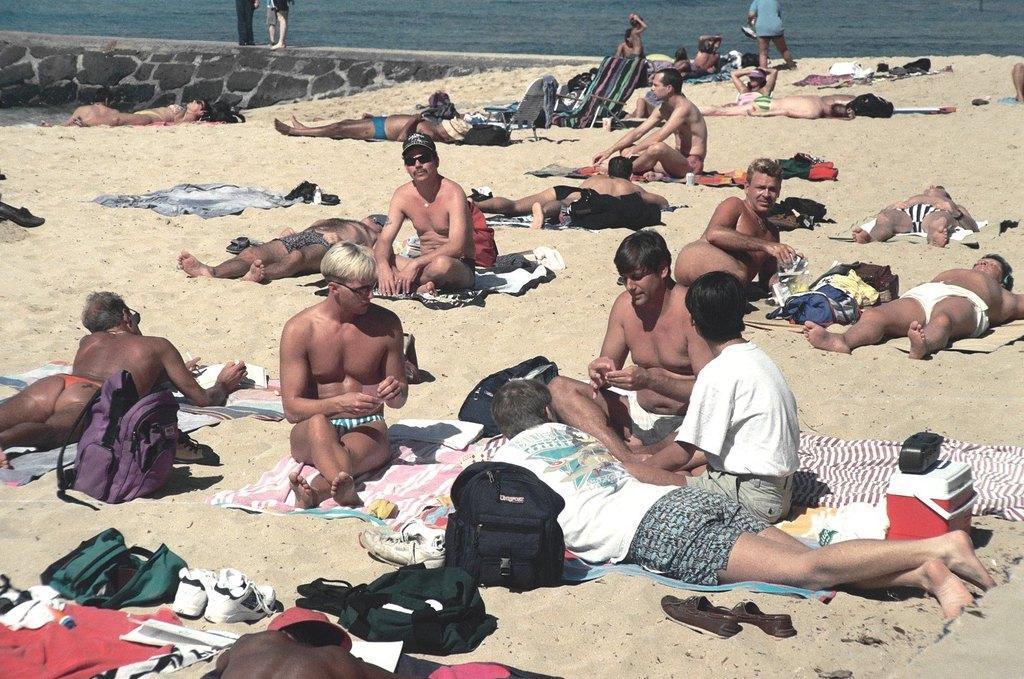How would you summarize this image in a sentence or two? In this image we can see group of persons sitting on the ground. In the foreground we can see group of bags and shoes placed on the ground. In the background we can see water. 